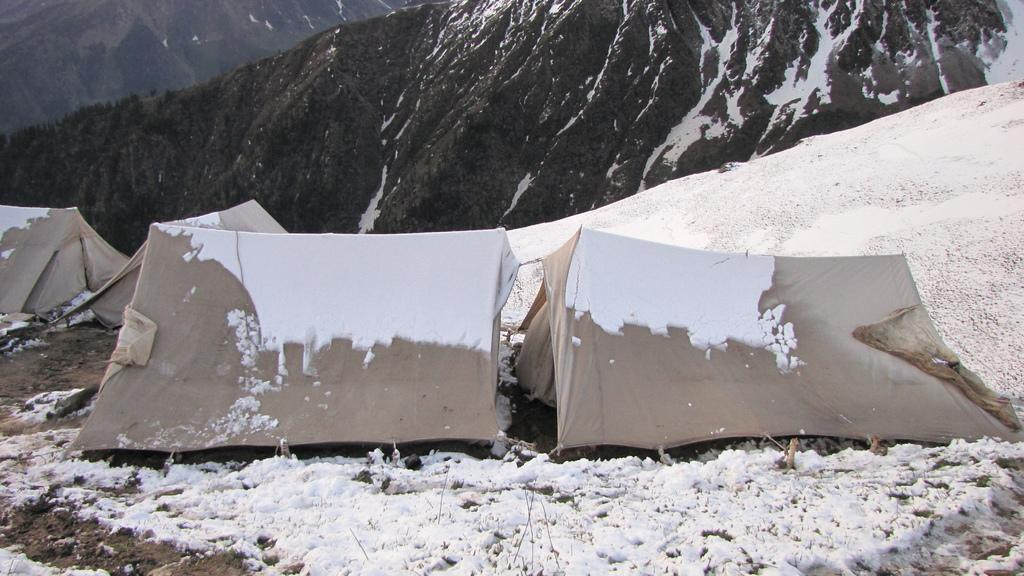What structures are located in the center of the image? There are tents in the center of the image. What type of terrain is visible at the bottom of the image? There is snow at the bottom of the image. What natural features can be seen in the background of the image? There are mountains and snow in the background of the image. What type of engine can be seen powering the waves in the image? There are no waves or engines present in the image. 